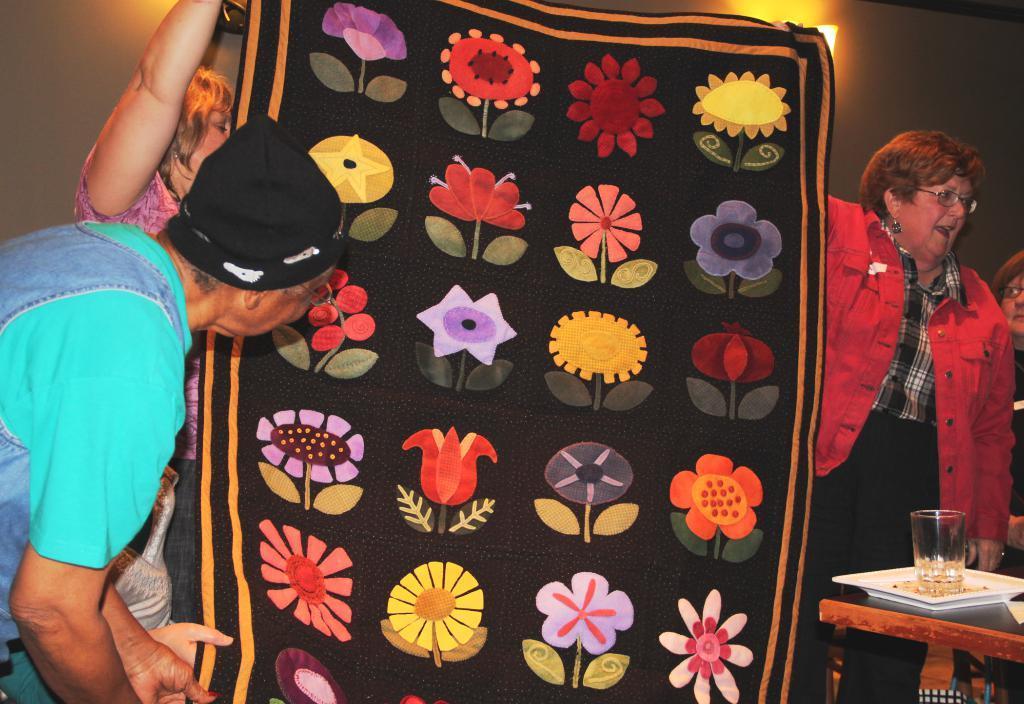Describe this image in one or two sentences. In this image, In the middle there is a black color cloth, In the left side there is a old man seeing the black cloth, In the right side there is a woman she is standing and holding a cloth, There is a table in the right side which is in yellow color on that table there is a plate which is in white color in that place there is a glass. 